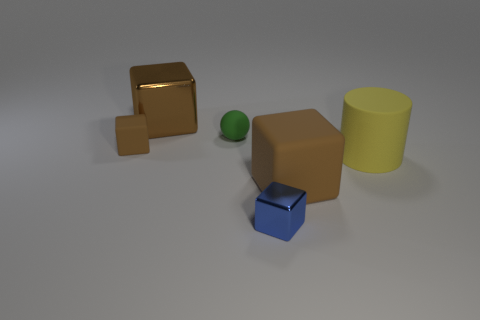Subtract all blue spheres. How many brown blocks are left? 3 Subtract 1 cubes. How many cubes are left? 3 Subtract all brown blocks. How many blocks are left? 1 Add 3 tiny purple rubber things. How many objects exist? 9 Subtract all green blocks. Subtract all gray balls. How many blocks are left? 4 Subtract all cylinders. How many objects are left? 5 Subtract all large yellow matte objects. Subtract all large objects. How many objects are left? 2 Add 3 tiny green matte objects. How many tiny green matte objects are left? 4 Add 1 yellow metal objects. How many yellow metal objects exist? 1 Subtract 0 purple cubes. How many objects are left? 6 